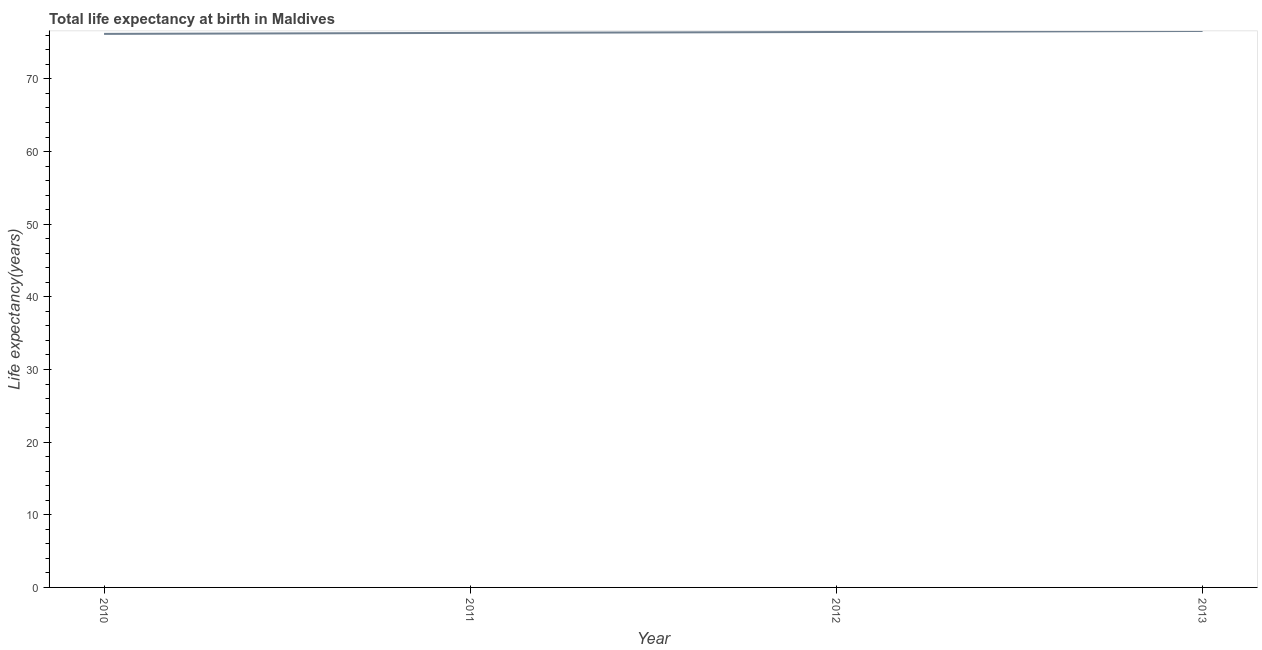What is the life expectancy at birth in 2011?
Make the answer very short. 76.34. Across all years, what is the maximum life expectancy at birth?
Provide a short and direct response. 76.6. Across all years, what is the minimum life expectancy at birth?
Provide a short and direct response. 76.2. What is the sum of the life expectancy at birth?
Provide a short and direct response. 305.6. What is the difference between the life expectancy at birth in 2010 and 2013?
Offer a terse response. -0.4. What is the average life expectancy at birth per year?
Your answer should be compact. 76.4. What is the median life expectancy at birth?
Make the answer very short. 76.4. In how many years, is the life expectancy at birth greater than 62 years?
Keep it short and to the point. 4. Do a majority of the years between 2013 and 2012 (inclusive) have life expectancy at birth greater than 18 years?
Your answer should be very brief. No. What is the ratio of the life expectancy at birth in 2011 to that in 2013?
Ensure brevity in your answer.  1. What is the difference between the highest and the second highest life expectancy at birth?
Make the answer very short. 0.14. Is the sum of the life expectancy at birth in 2010 and 2013 greater than the maximum life expectancy at birth across all years?
Offer a very short reply. Yes. What is the difference between the highest and the lowest life expectancy at birth?
Provide a succinct answer. 0.4. How many lines are there?
Keep it short and to the point. 1. How many years are there in the graph?
Your response must be concise. 4. What is the difference between two consecutive major ticks on the Y-axis?
Your answer should be very brief. 10. What is the title of the graph?
Ensure brevity in your answer.  Total life expectancy at birth in Maldives. What is the label or title of the Y-axis?
Offer a very short reply. Life expectancy(years). What is the Life expectancy(years) of 2010?
Your answer should be compact. 76.2. What is the Life expectancy(years) of 2011?
Provide a short and direct response. 76.34. What is the Life expectancy(years) in 2012?
Provide a succinct answer. 76.46. What is the Life expectancy(years) in 2013?
Provide a short and direct response. 76.6. What is the difference between the Life expectancy(years) in 2010 and 2011?
Offer a very short reply. -0.14. What is the difference between the Life expectancy(years) in 2010 and 2012?
Your answer should be very brief. -0.26. What is the difference between the Life expectancy(years) in 2010 and 2013?
Make the answer very short. -0.4. What is the difference between the Life expectancy(years) in 2011 and 2012?
Provide a succinct answer. -0.12. What is the difference between the Life expectancy(years) in 2011 and 2013?
Offer a very short reply. -0.27. What is the difference between the Life expectancy(years) in 2012 and 2013?
Provide a short and direct response. -0.14. What is the ratio of the Life expectancy(years) in 2010 to that in 2011?
Make the answer very short. 1. What is the ratio of the Life expectancy(years) in 2010 to that in 2012?
Make the answer very short. 1. What is the ratio of the Life expectancy(years) in 2011 to that in 2012?
Your answer should be very brief. 1. What is the ratio of the Life expectancy(years) in 2011 to that in 2013?
Make the answer very short. 1. 